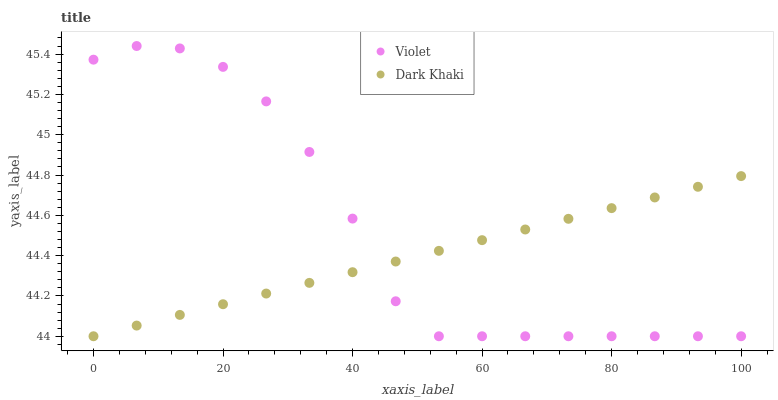Does Dark Khaki have the minimum area under the curve?
Answer yes or no. Yes. Does Violet have the maximum area under the curve?
Answer yes or no. Yes. Does Violet have the minimum area under the curve?
Answer yes or no. No. Is Dark Khaki the smoothest?
Answer yes or no. Yes. Is Violet the roughest?
Answer yes or no. Yes. Is Violet the smoothest?
Answer yes or no. No. Does Dark Khaki have the lowest value?
Answer yes or no. Yes. Does Violet have the highest value?
Answer yes or no. Yes. Does Dark Khaki intersect Violet?
Answer yes or no. Yes. Is Dark Khaki less than Violet?
Answer yes or no. No. Is Dark Khaki greater than Violet?
Answer yes or no. No. 